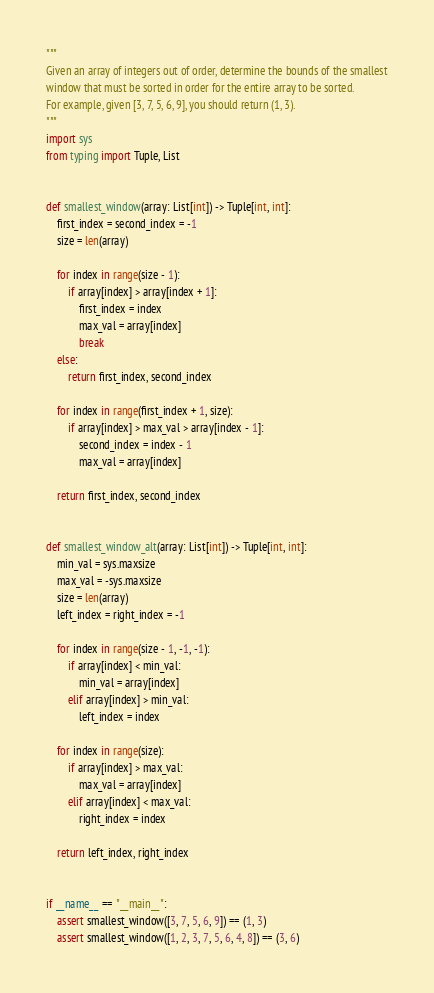<code> <loc_0><loc_0><loc_500><loc_500><_Python_>"""
Given an array of integers out of order, determine the bounds of the smallest
window that must be sorted in order for the entire array to be sorted.
For example, given [3, 7, 5, 6, 9], you should return (1, 3).
"""
import sys
from typing import Tuple, List


def smallest_window(array: List[int]) -> Tuple[int, int]:
    first_index = second_index = -1
    size = len(array)

    for index in range(size - 1):
        if array[index] > array[index + 1]:
            first_index = index
            max_val = array[index]
            break
    else:
        return first_index, second_index

    for index in range(first_index + 1, size):
        if array[index] > max_val > array[index - 1]:
            second_index = index - 1
            max_val = array[index]

    return first_index, second_index


def smallest_window_alt(array: List[int]) -> Tuple[int, int]:
    min_val = sys.maxsize
    max_val = -sys.maxsize
    size = len(array)
    left_index = right_index = -1

    for index in range(size - 1, -1, -1):
        if array[index] < min_val:
            min_val = array[index]
        elif array[index] > min_val:
            left_index = index

    for index in range(size):
        if array[index] > max_val:
            max_val = array[index]
        elif array[index] < max_val:
            right_index = index

    return left_index, right_index


if __name__ == "__main__":
    assert smallest_window([3, 7, 5, 6, 9]) == (1, 3)
    assert smallest_window([1, 2, 3, 7, 5, 6, 4, 8]) == (3, 6)</code> 